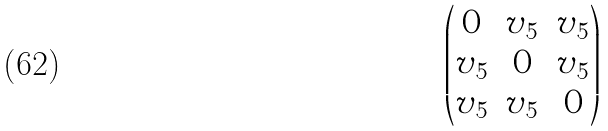<formula> <loc_0><loc_0><loc_500><loc_500>\begin{pmatrix} 0 & v _ { 5 } & v _ { 5 } \\ v _ { 5 } & 0 & v _ { 5 } \\ v _ { 5 } & v _ { 5 } & 0 \\ \end{pmatrix}</formula> 